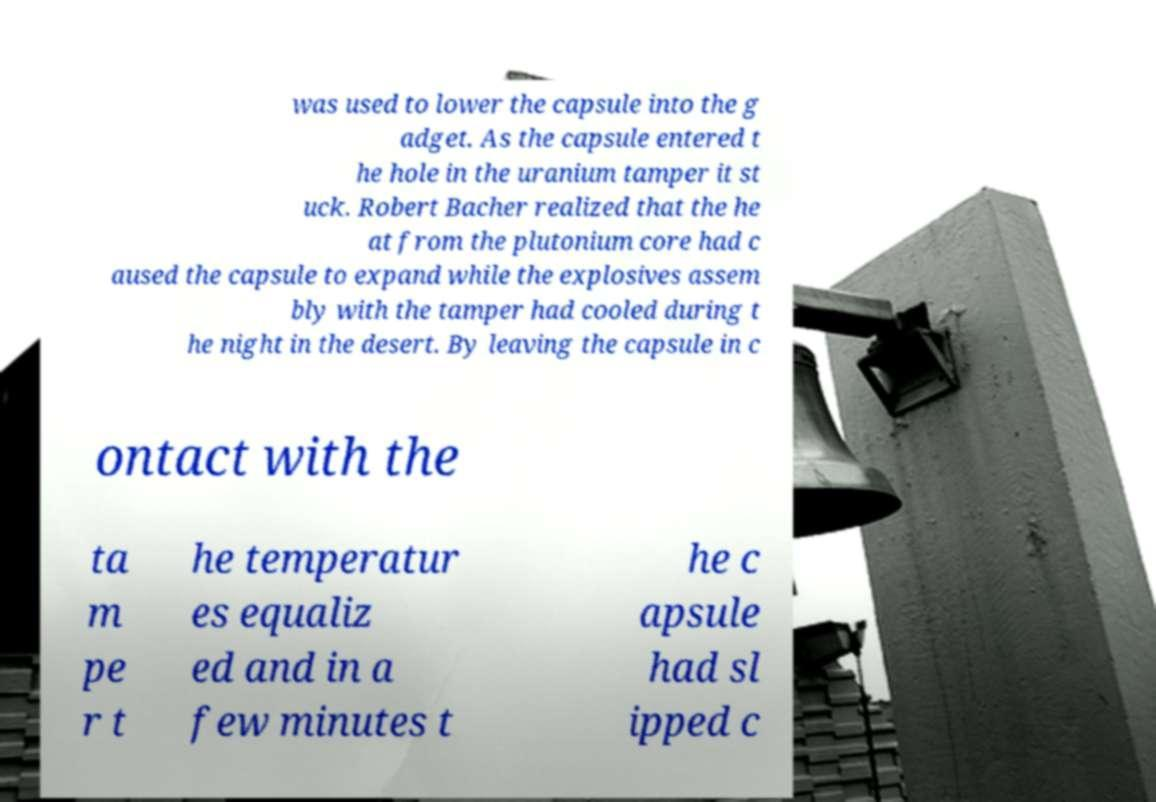Could you extract and type out the text from this image? was used to lower the capsule into the g adget. As the capsule entered t he hole in the uranium tamper it st uck. Robert Bacher realized that the he at from the plutonium core had c aused the capsule to expand while the explosives assem bly with the tamper had cooled during t he night in the desert. By leaving the capsule in c ontact with the ta m pe r t he temperatur es equaliz ed and in a few minutes t he c apsule had sl ipped c 